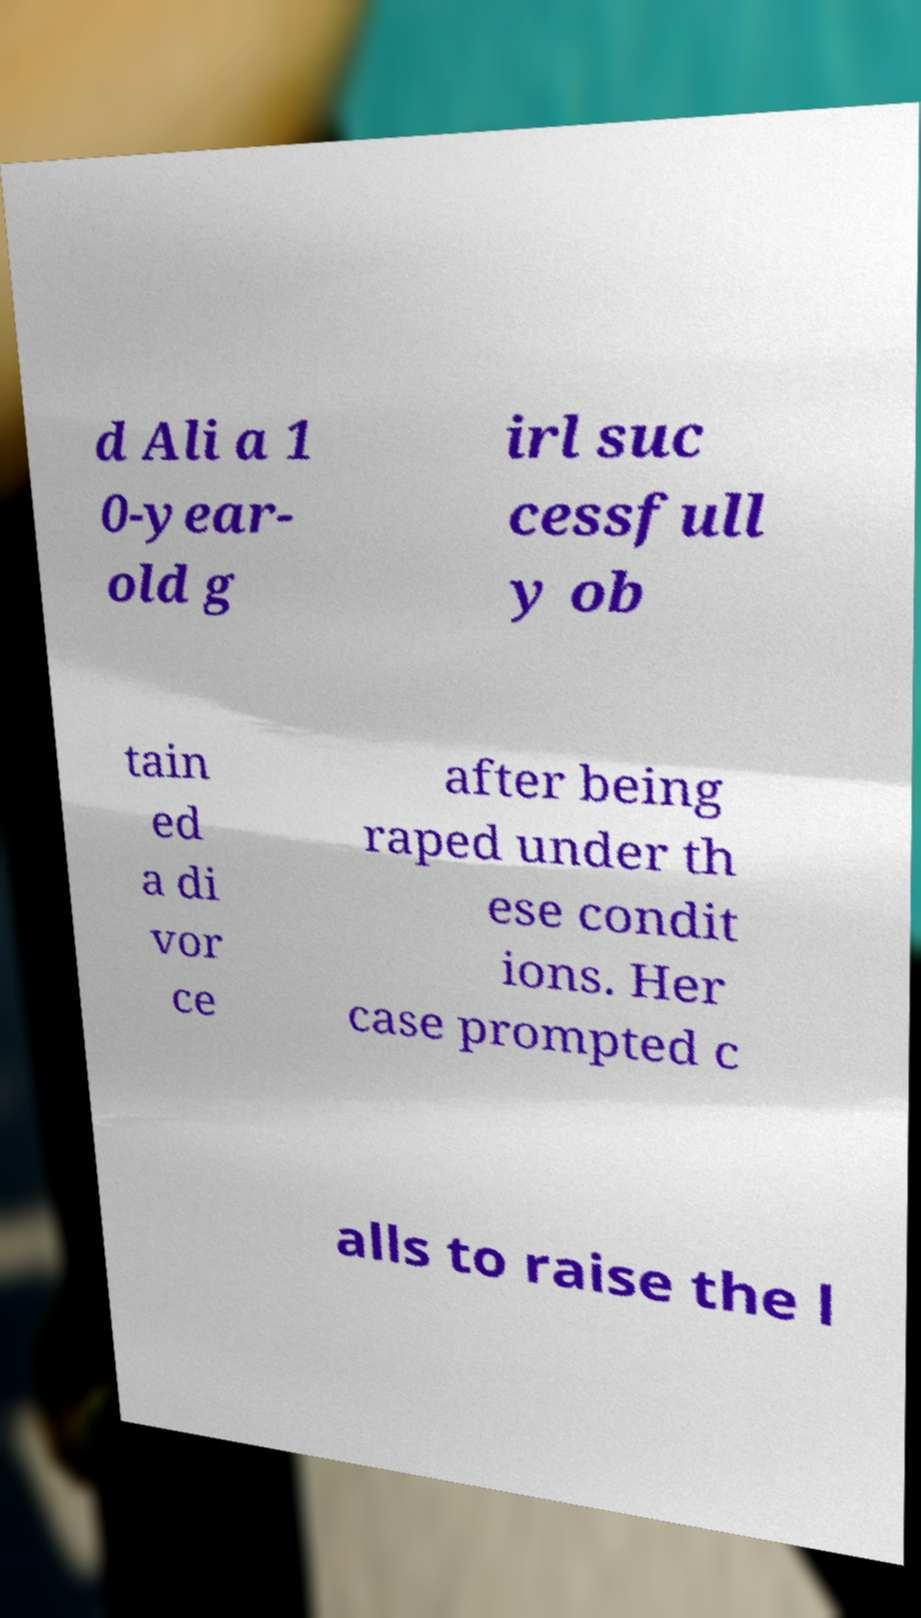Could you assist in decoding the text presented in this image and type it out clearly? d Ali a 1 0-year- old g irl suc cessfull y ob tain ed a di vor ce after being raped under th ese condit ions. Her case prompted c alls to raise the l 